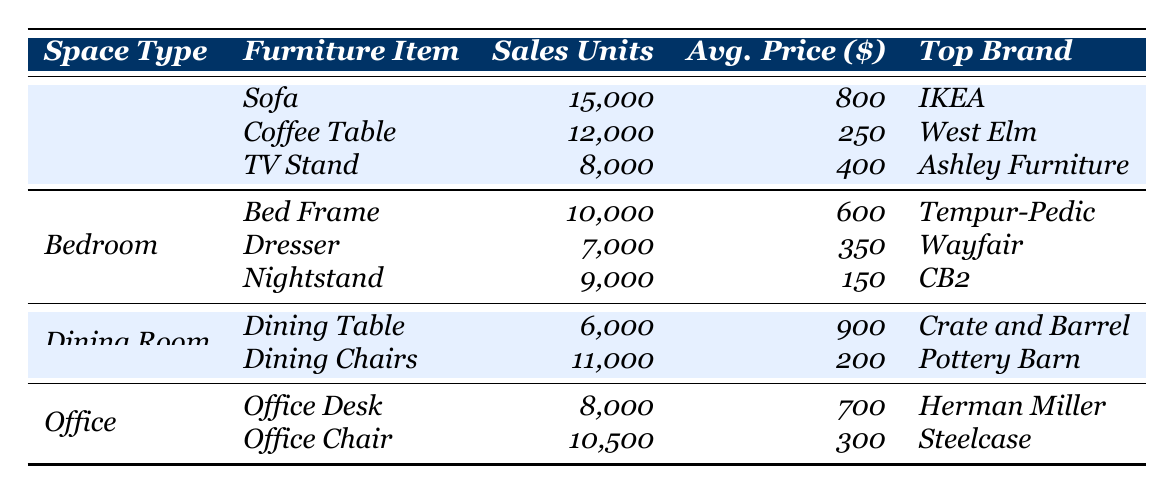What's the top-selling furniture item in the Living Room? The highest sales units in the Living Room category is for the Sofa, which sold 15,000 units.
Answer: Sofa What brand is the top seller for Bedroom furniture? The top brand for the Bed Frame in the Bedroom category is Tempur-Pedic.
Answer: Tempur-Pedic How many units of Dining Chairs were sold? The Dining Chairs in the Dining Room category sold 11,000 units, as stated in the table.
Answer: 11,000 Which furniture item had the highest average price in the Office? The Office Desk has the highest average price at 700 dollars compared to the Office Chair.
Answer: Office Desk What is the total number of sales units for furniture in the Bedroom? Adding the sales units for Bed Frame (10,000), Dresser (7,000), and Nightstand (9,000) gives a total of 26,000 units (10,000 + 7,000 + 9,000).
Answer: 26,000 Which space type had the least sales in a single item? The Dining Table had the least sales in a single item with 6,000 units sold in the Dining Room category.
Answer: Dining Room Is there a furniture item with an average price below 200 dollars? Yes, the Nightstand has an average price of 150 dollars, which is below 200 dollars.
Answer: Yes What is the average sales units for furniture items in the Living Room? The total sales units for Living Room items are 15,000 + 12,000 + 8,000 = 35,000. Dividing by 3 items gives an average of 11,666.67 (35,000/3).
Answer: 11,666.67 How many more units of Coffee Tables were sold compared to TV Stands? The difference in sales units is 12,000 (Coffee Tables) - 8,000 (TV Stands) = 4,000 more units sold for Coffee Tables.
Answer: 4,000 What is the total average price for all furniture items in the Office? The average price for Office Desk is 700 dollars and for Office Chair is 300 dollars. Their total price is 700 + 300 = 1,000, and with 2 items, the average is 500 dollars (1,000/2).
Answer: 500 